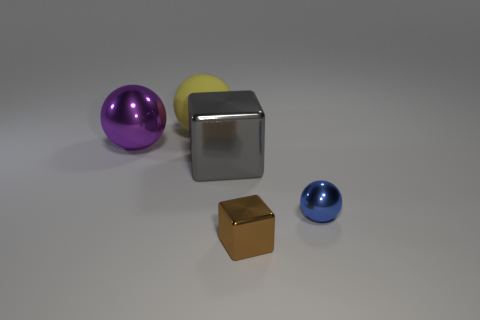There is a big object that is left of the big block and in front of the large matte ball; what is its shape?
Your answer should be compact. Sphere. What number of spheres are tiny brown objects or small metal things?
Provide a succinct answer. 1. Is the number of tiny brown shiny cubes that are left of the large yellow sphere less than the number of large purple objects?
Give a very brief answer. Yes. There is a shiny thing that is both on the right side of the big gray block and to the left of the tiny blue sphere; what is its color?
Keep it short and to the point. Brown. How many other things are there of the same shape as the big yellow object?
Provide a succinct answer. 2. Are there fewer large objects behind the large gray object than small blue objects left of the small brown object?
Provide a succinct answer. No. Does the brown thing have the same material as the large thing that is right of the big yellow rubber ball?
Make the answer very short. Yes. Is there anything else that has the same material as the large gray cube?
Your response must be concise. Yes. Are there more cyan objects than yellow spheres?
Offer a terse response. No. What is the shape of the big metallic thing to the right of the large metal object that is on the left side of the big shiny thing right of the yellow object?
Offer a terse response. Cube. 